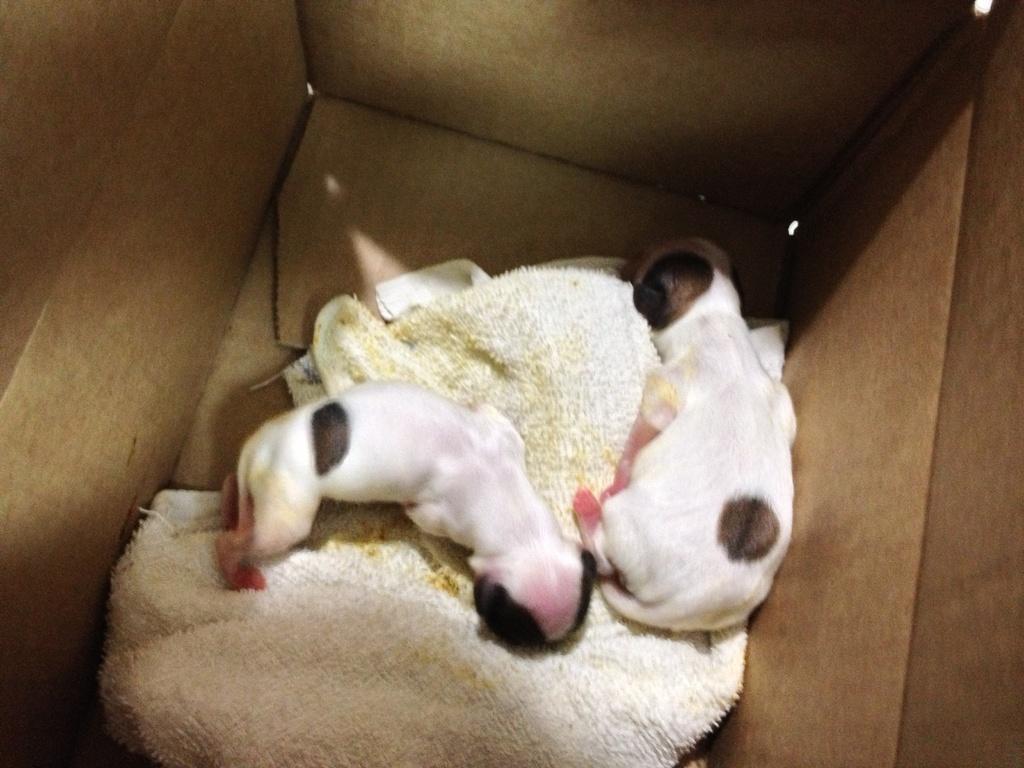Describe this image in one or two sentences. 2 puppies are present inside a box, on a cloth. 